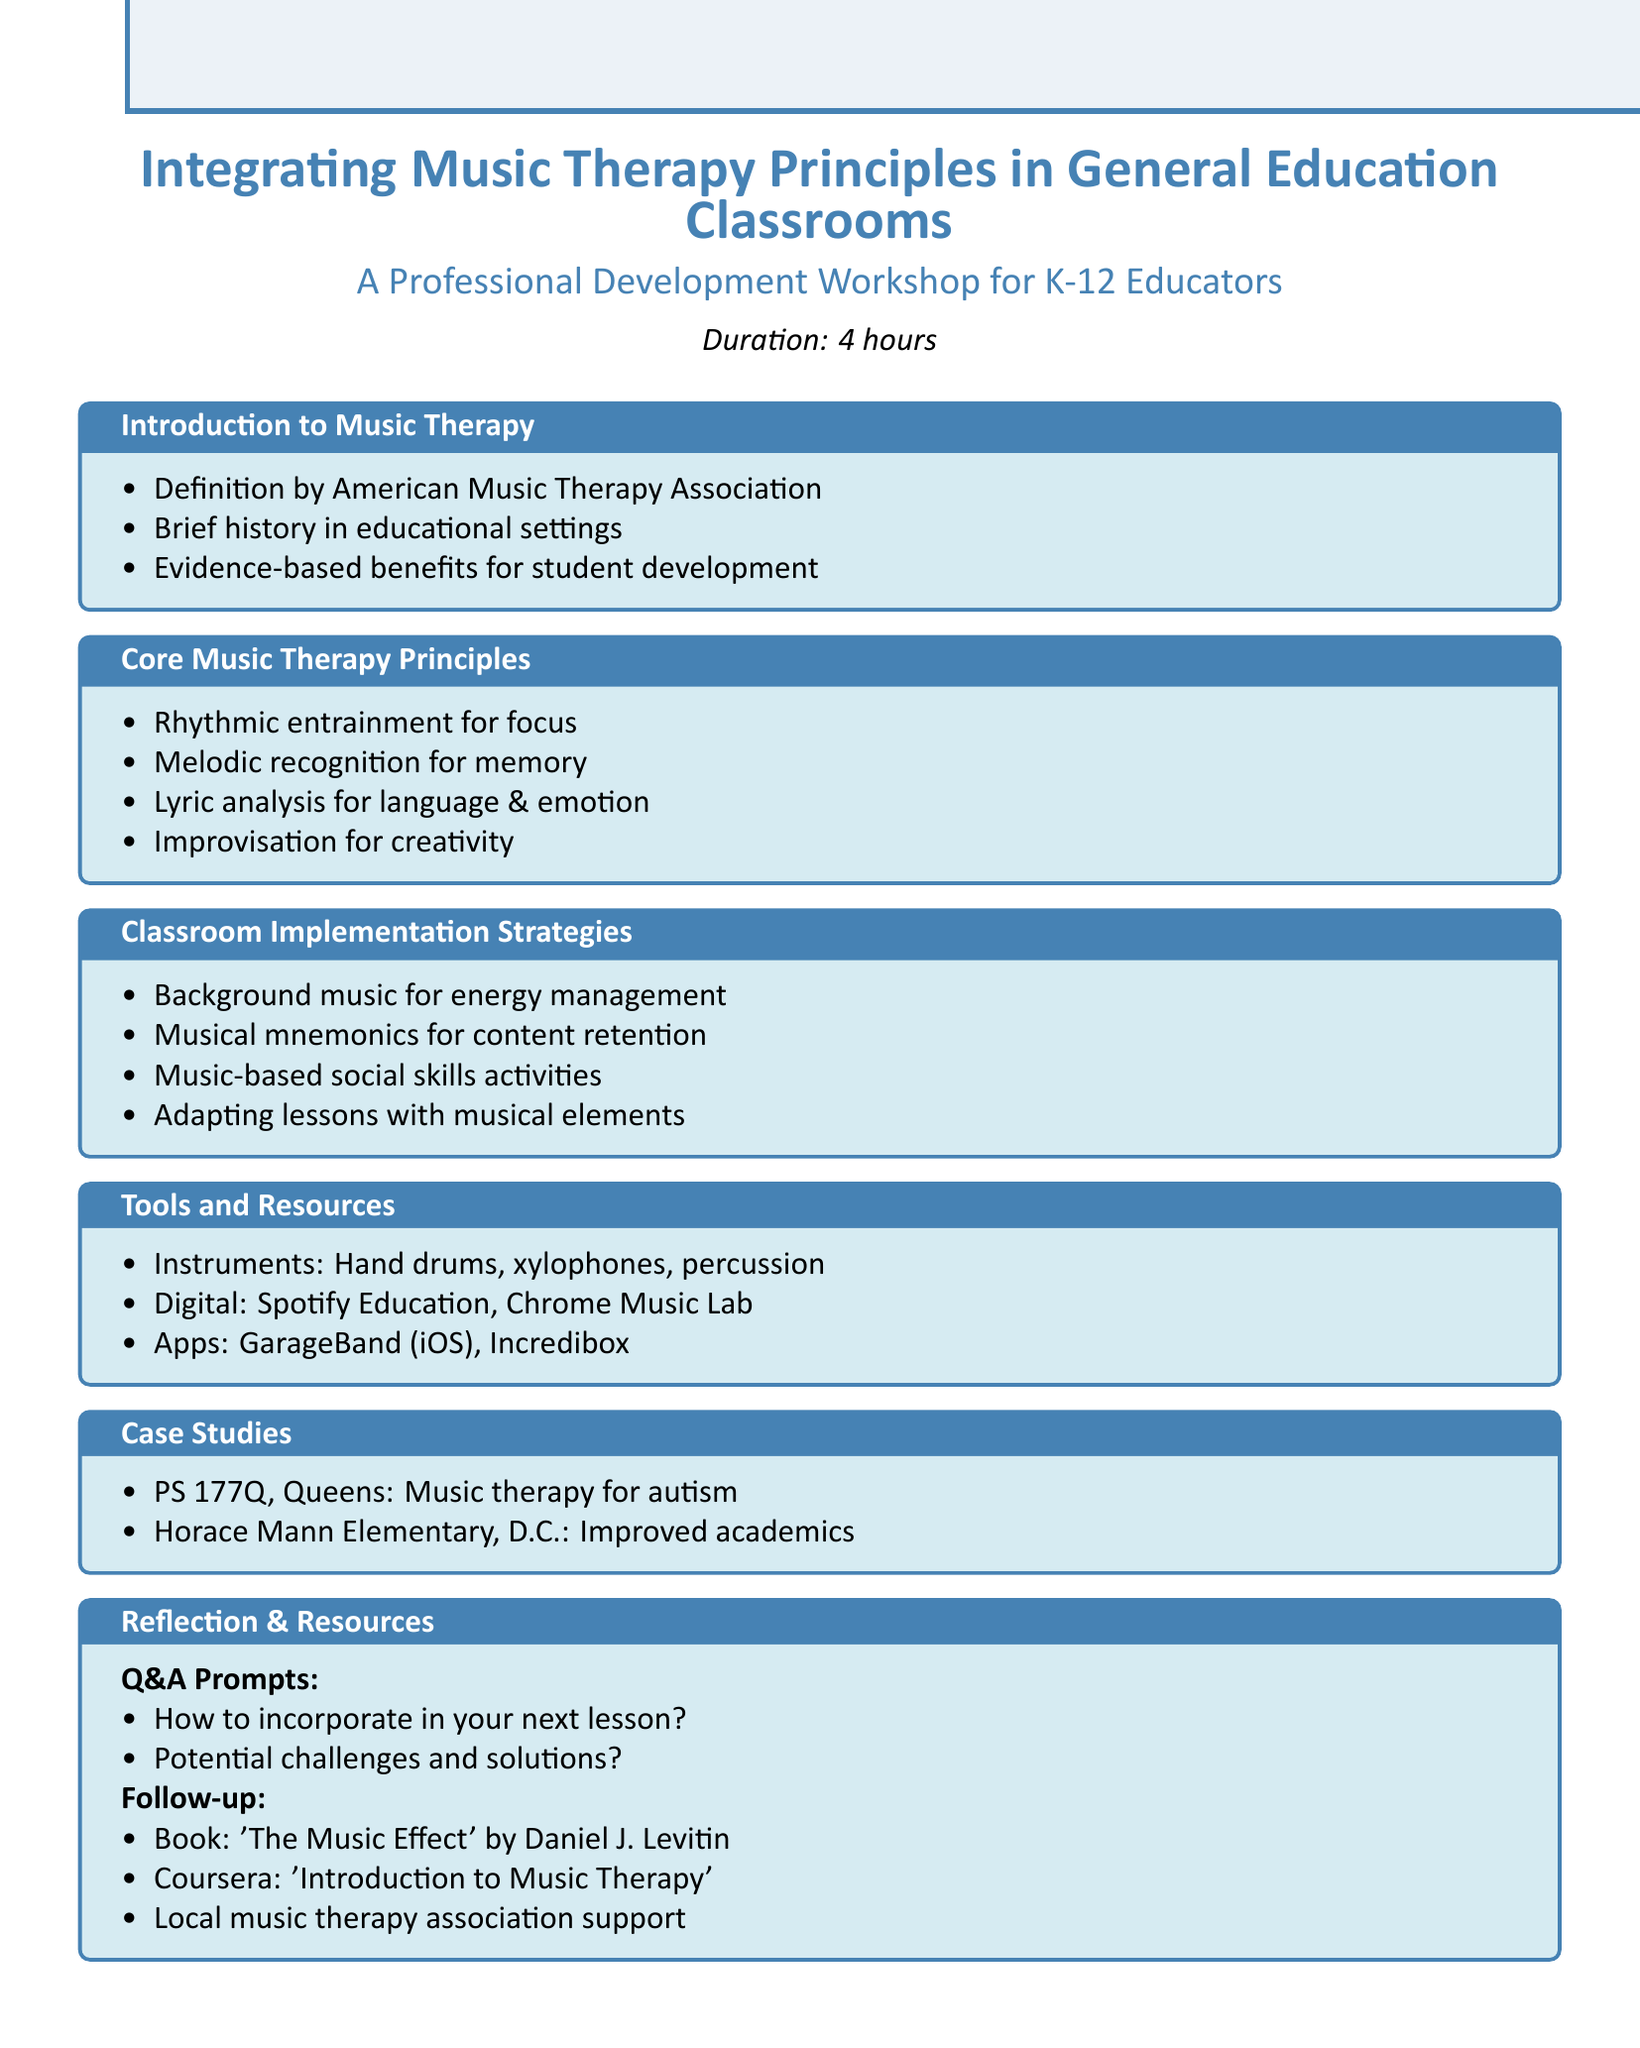What is the title of the workshop? The title of the workshop is presented at the beginning of the document.
Answer: Integrating Music Therapy Principles in General Education Classrooms Who is the target audience? The target audience is specified in the document, indicating who the workshop is designed for.
Answer: K-12 teachers and educational staff How long is the workshop duration? The duration is mentioned in the details section of the document.
Answer: 4 hours Name one core music therapy principle mentioned. There are several core principles listed in the document; one example can be pulled directly from that list.
Answer: Rhythmic entrainment for focus and attention What is one recommended instrument for classroom implementation? The tools and resources section specifies various instruments that can be utilized, thus providing a direct answer.
Answer: Hand drums Which case study involved students with autism? The document presents specific examples of case studies under the case studies section.
Answer: PS 177Q in Queens, NY What is one digital resource recommended? The tools and resources section lists digital tools that can be used; selecting one from the list would provide the answer.
Answer: Spotify Education playlists What is one Q&A prompt provided in the workshop? The reflection and resources section includes several prompts for discussion, thus providing a specific example for this question.
Answer: How can you incorporate one music therapy principle in your next lesson? 